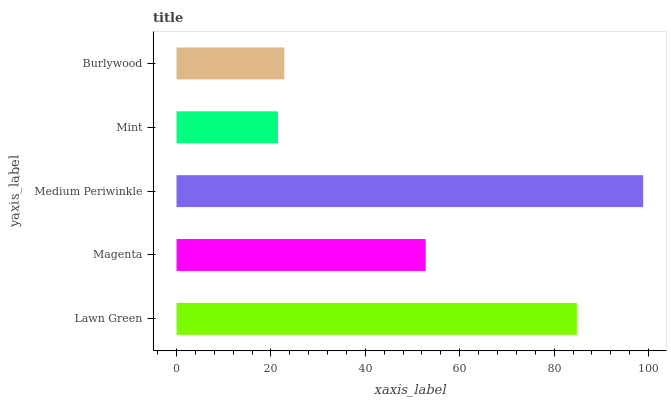Is Mint the minimum?
Answer yes or no. Yes. Is Medium Periwinkle the maximum?
Answer yes or no. Yes. Is Magenta the minimum?
Answer yes or no. No. Is Magenta the maximum?
Answer yes or no. No. Is Lawn Green greater than Magenta?
Answer yes or no. Yes. Is Magenta less than Lawn Green?
Answer yes or no. Yes. Is Magenta greater than Lawn Green?
Answer yes or no. No. Is Lawn Green less than Magenta?
Answer yes or no. No. Is Magenta the high median?
Answer yes or no. Yes. Is Magenta the low median?
Answer yes or no. Yes. Is Mint the high median?
Answer yes or no. No. Is Burlywood the low median?
Answer yes or no. No. 